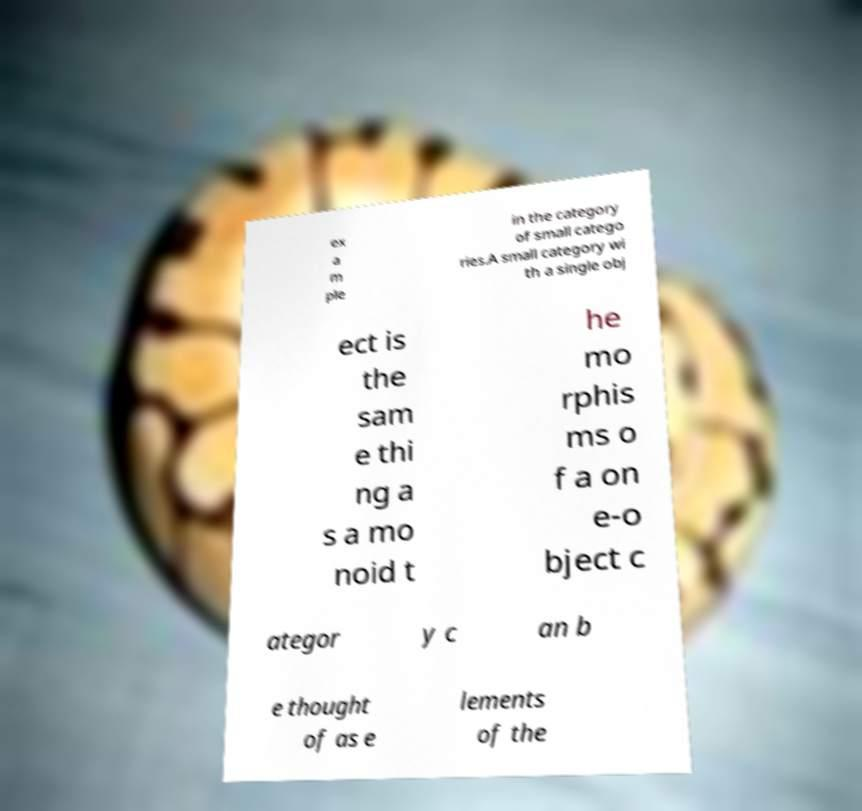Can you read and provide the text displayed in the image?This photo seems to have some interesting text. Can you extract and type it out for me? ex a m ple in the category of small catego ries.A small category wi th a single obj ect is the sam e thi ng a s a mo noid t he mo rphis ms o f a on e-o bject c ategor y c an b e thought of as e lements of the 